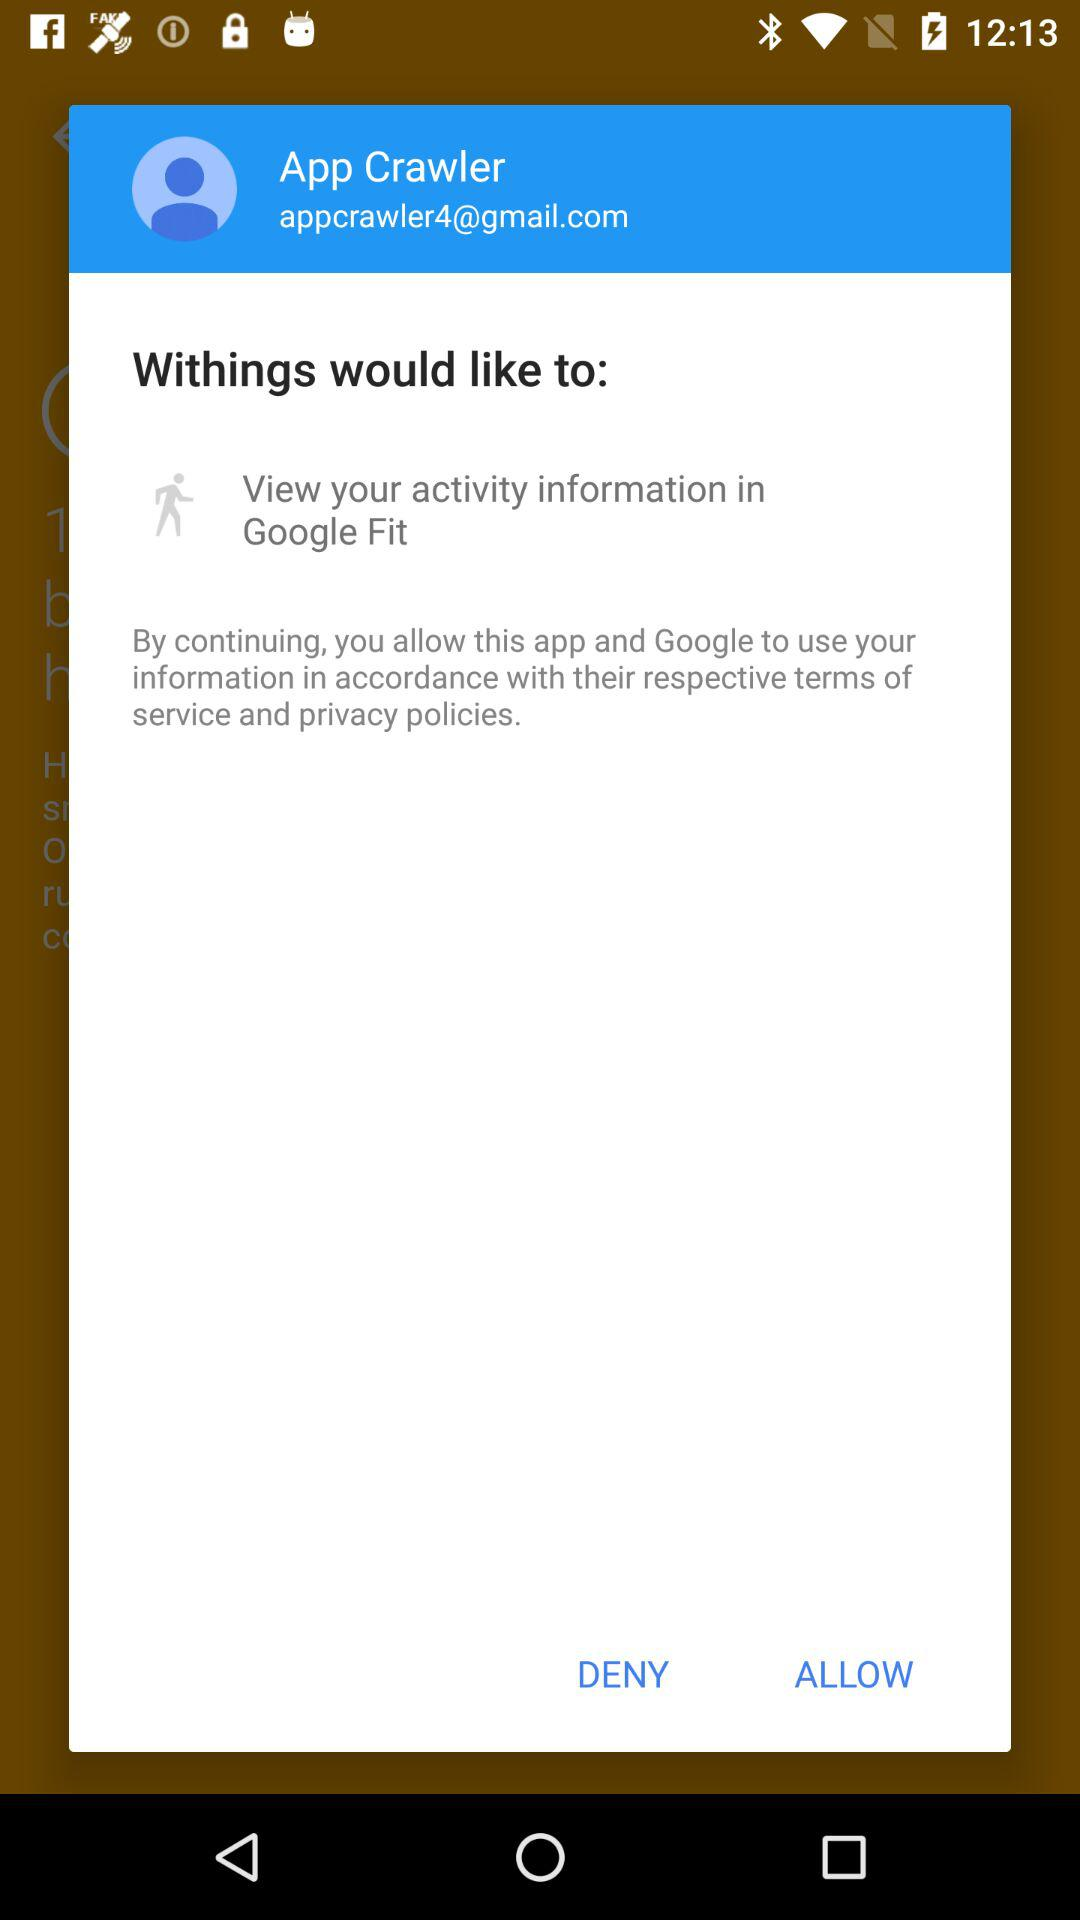What is the user name? The user name is App Crawler. 